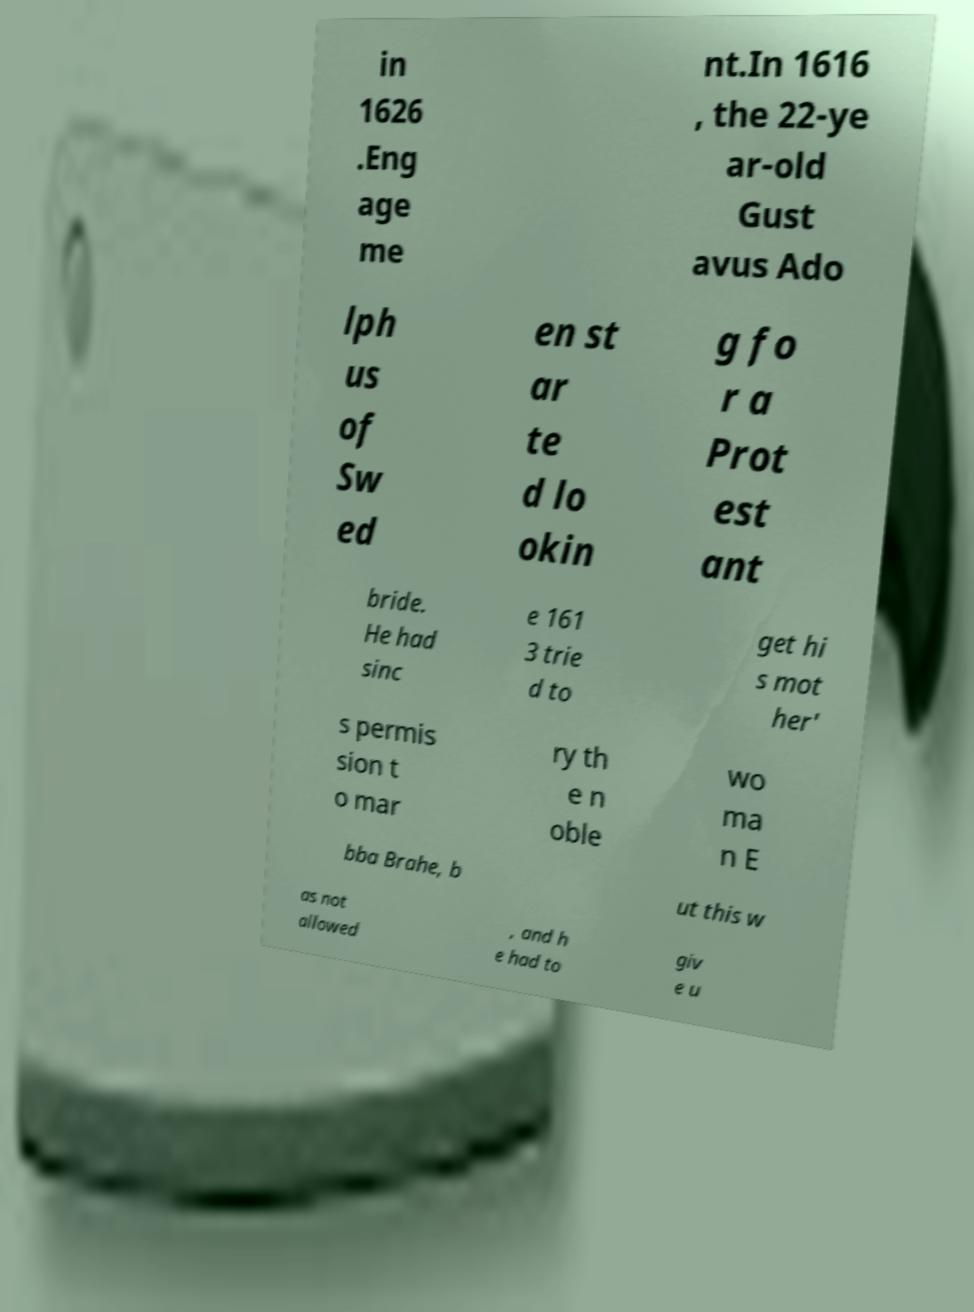Please read and relay the text visible in this image. What does it say? in 1626 .Eng age me nt.In 1616 , the 22-ye ar-old Gust avus Ado lph us of Sw ed en st ar te d lo okin g fo r a Prot est ant bride. He had sinc e 161 3 trie d to get hi s mot her' s permis sion t o mar ry th e n oble wo ma n E bba Brahe, b ut this w as not allowed , and h e had to giv e u 